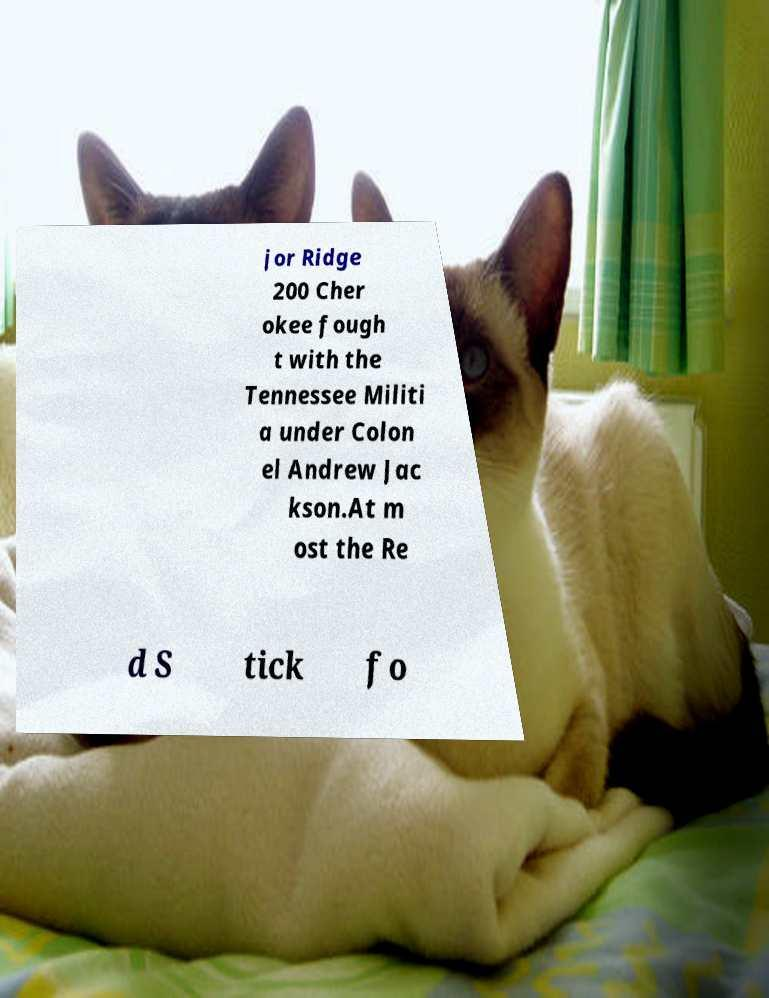Can you read and provide the text displayed in the image?This photo seems to have some interesting text. Can you extract and type it out for me? jor Ridge 200 Cher okee fough t with the Tennessee Militi a under Colon el Andrew Jac kson.At m ost the Re d S tick fo 